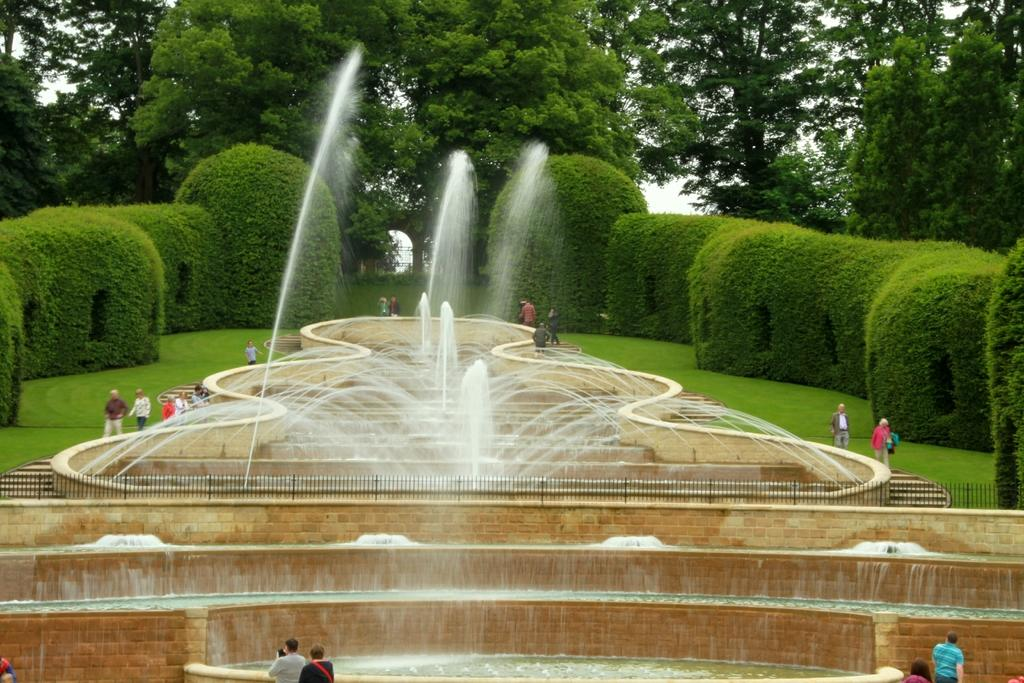What type of structures can be seen in the image? There are water fountains in the image. Are there any living beings in the image? Yes, there are people in the image. What type of natural elements are present in the image? There are trees and plants in the image. What type of ground cover is visible in the image? There is grass on the floor in the image. How many cats can be seen stretching on the grass in the image? There are no cats present in the image, so it is not possible to determine how many might be stretching on the grass. 